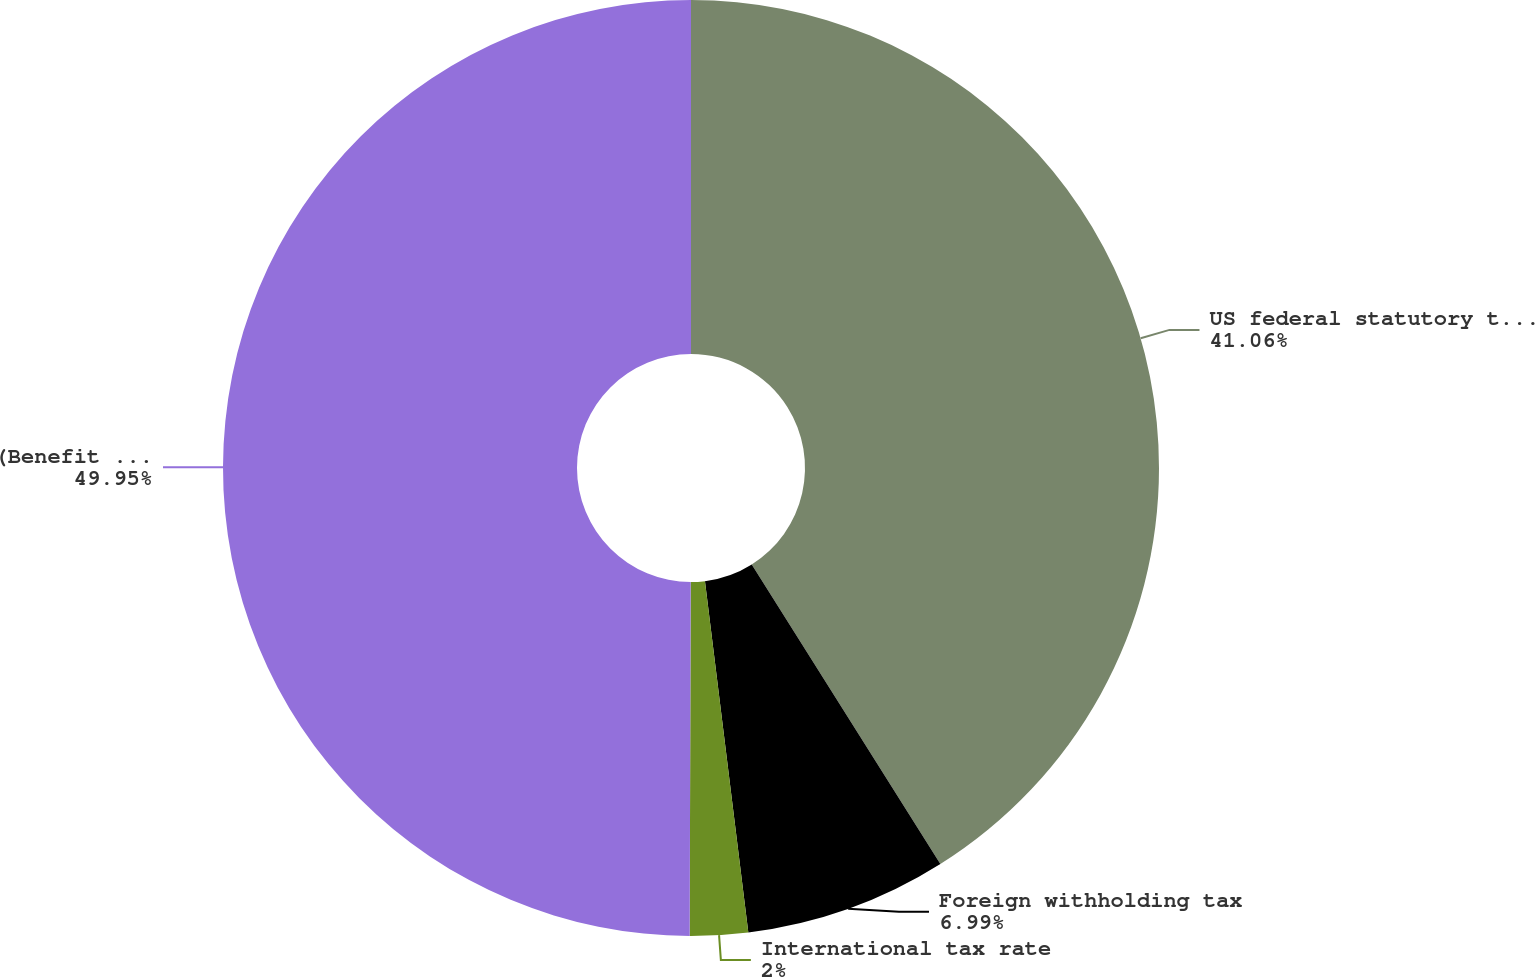Convert chart to OTSL. <chart><loc_0><loc_0><loc_500><loc_500><pie_chart><fcel>US federal statutory tax rate<fcel>Foreign withholding tax<fcel>International tax rate<fcel>(Benefit from) provision for<nl><fcel>41.06%<fcel>6.99%<fcel>2.0%<fcel>49.96%<nl></chart> 